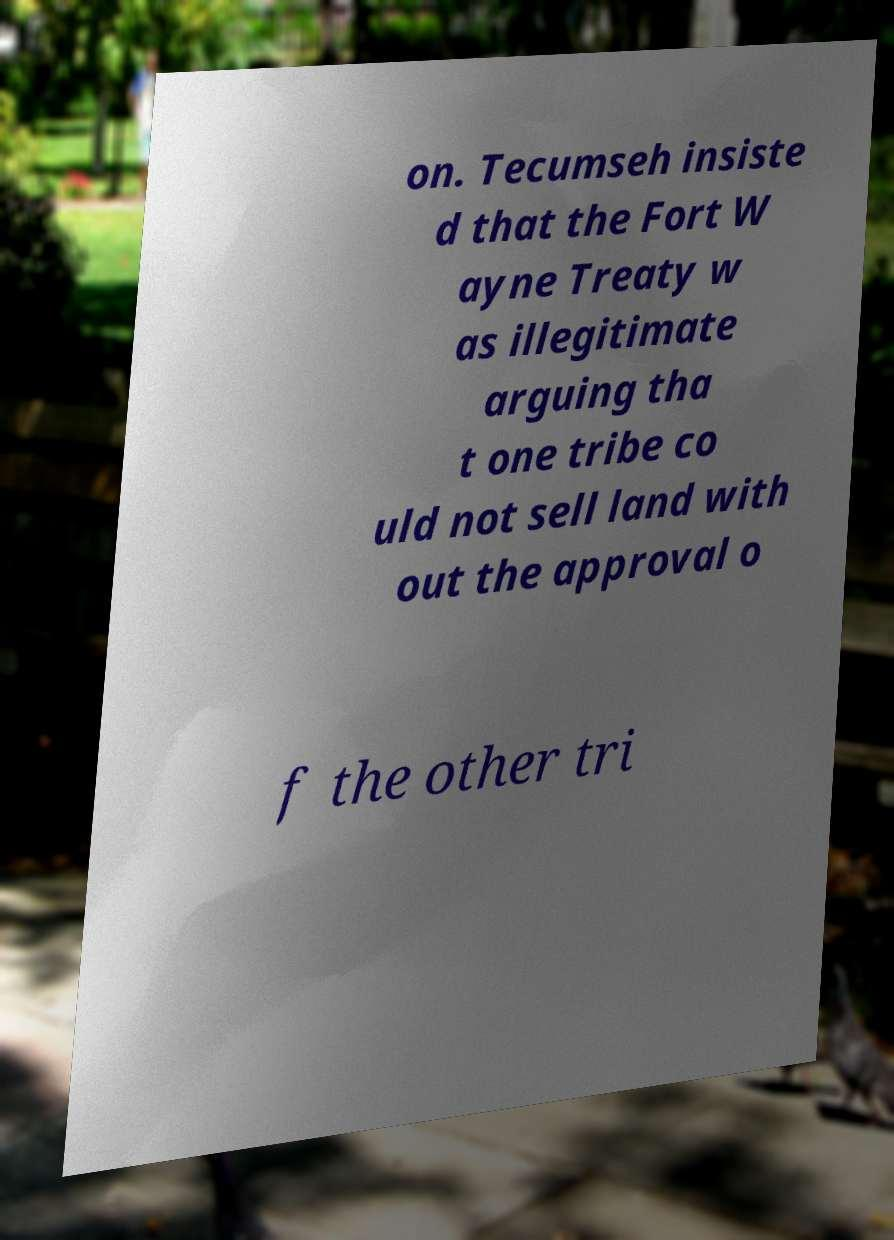There's text embedded in this image that I need extracted. Can you transcribe it verbatim? on. Tecumseh insiste d that the Fort W ayne Treaty w as illegitimate arguing tha t one tribe co uld not sell land with out the approval o f the other tri 